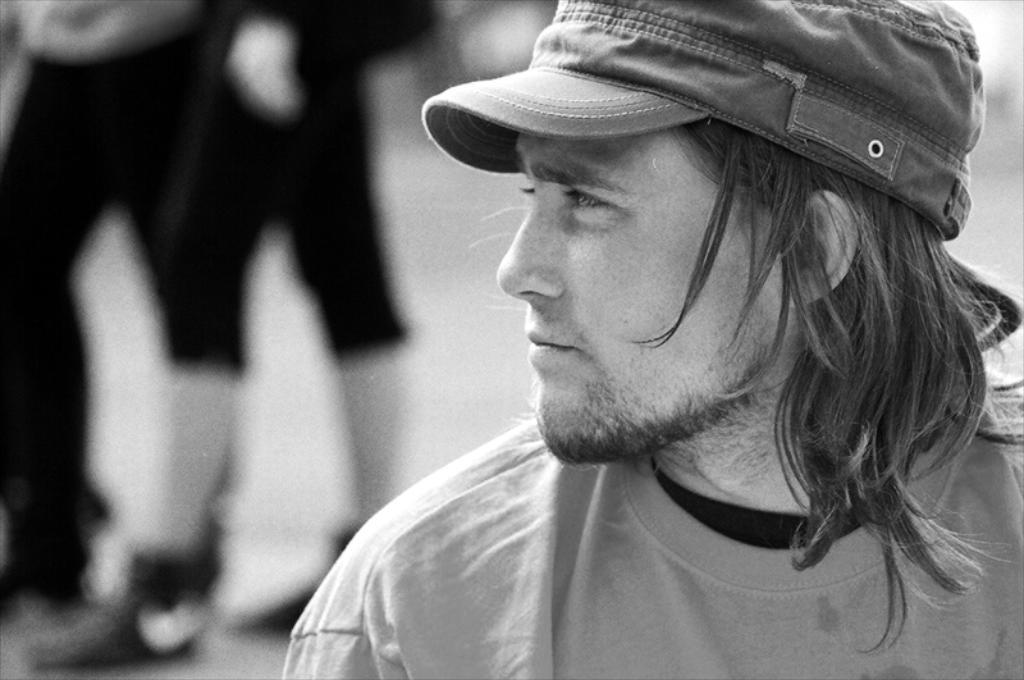Who or what is the main subject in the image? There is a person in the image. What is the person wearing on their head? The person is wearing a cap. Can you describe the person's legs in the image? The person's legs are visible on the left side of the image. Reasoning: Let's think step by breaking down the process of creating the conversation. We start by identifying the main subject in the image, which is the person. Then, we focus on specific details about the person, such as their headwear and the visibility of their legs. Each question is designed to provide a clear and concise answer based on the provided facts. Absurd Question/Answer: What type of jam is being spread on the person's shoes in the image? There is no jam or shoes present in the image; the person is wearing a cap and their legs are visible on the left side. 